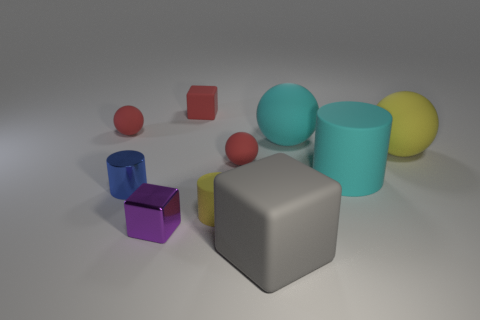Subtract all cyan balls. How many balls are left? 3 Subtract all blue cylinders. How many cylinders are left? 2 Subtract 2 spheres. How many spheres are left? 2 Add 6 big cyan matte things. How many big cyan matte things exist? 8 Subtract 0 gray balls. How many objects are left? 10 Subtract all cylinders. How many objects are left? 7 Subtract all cyan cylinders. Subtract all gray balls. How many cylinders are left? 2 Subtract all brown spheres. How many yellow cylinders are left? 1 Subtract all big red shiny objects. Subtract all large rubber balls. How many objects are left? 8 Add 4 tiny yellow matte cylinders. How many tiny yellow matte cylinders are left? 5 